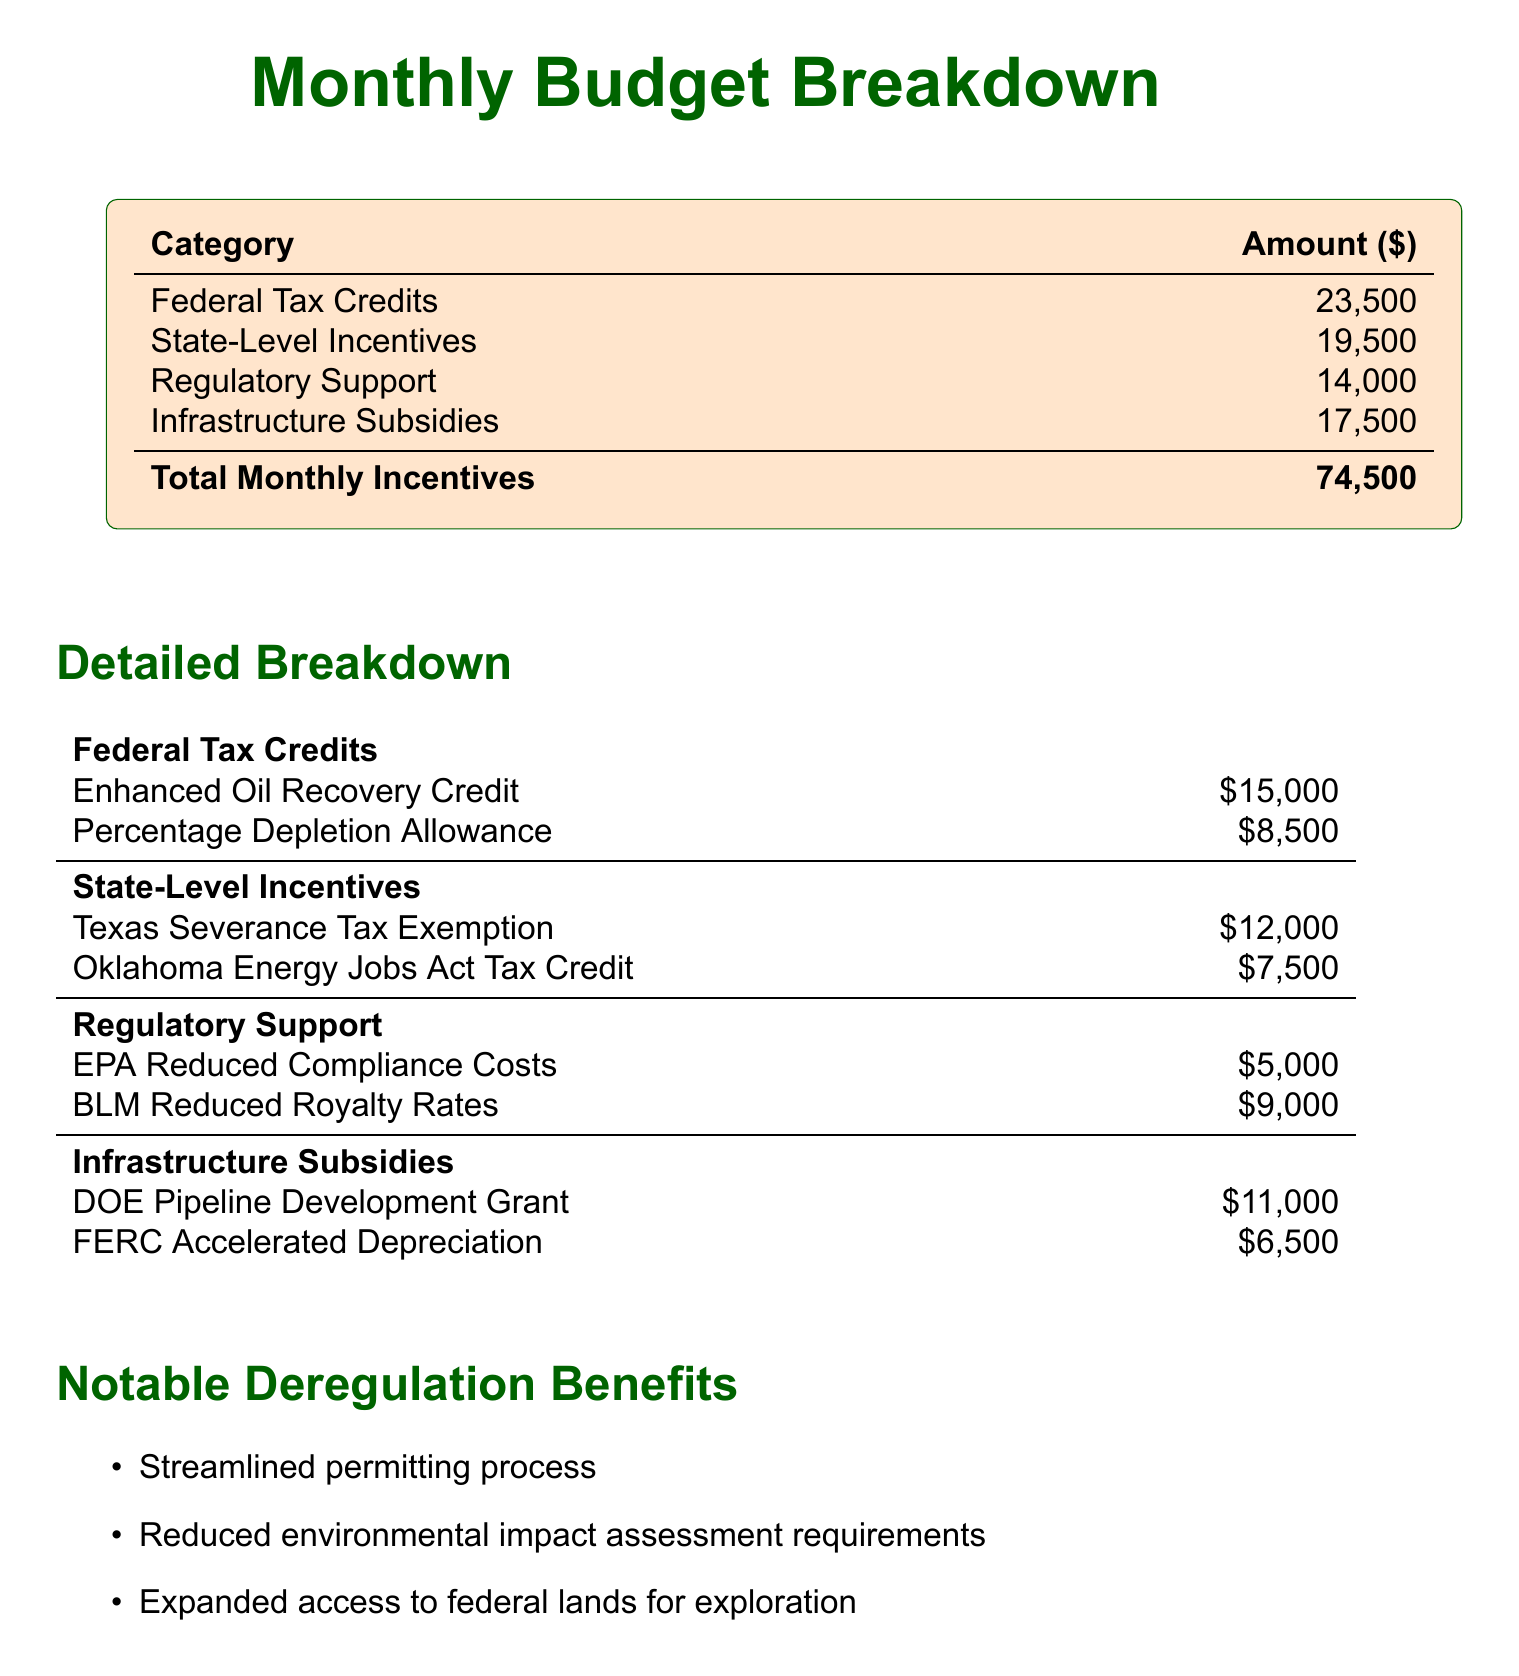What is the total amount of monthly incentives? The total monthly incentives are calculated by adding up all the categories listed in the budget.
Answer: 74,500 How much is received from Federal Tax Credits? The Federal Tax Credits total is specifically listed in the budget breakdown.
Answer: 23,500 What is the amount attributed to the Texas Severance Tax Exemption? This amount is specified in the detailed breakdown section under State-Level Incentives.
Answer: 12,000 Which category has the highest amount of subsidies? By comparing all listed categories, the one with the highest amount can be identified.
Answer: Federal Tax Credits What is the value of the Enhanced Oil Recovery Credit? This value is provided in the detailed breakdown for Federal Tax Credits.
Answer: 15,000 How much do the EPA Reduced Compliance Costs contribute to the total? This amount is found under the Regulatory Support section of the document.
Answer: 5,000 What is one benefit of deregulation mentioned in the document? The document lists notable deregulation benefits, and one can be directly quoted.
Answer: Streamlined permitting process How much is received from Infrastructure Subsidies? The total received from Infrastructure Subsidies is listed clearly in the document.
Answer: 17,500 What is the amount for the BLM Reduced Royalty Rates? This amount can be found in the Regulatory Support section of the detailed breakdown.
Answer: 9,000 